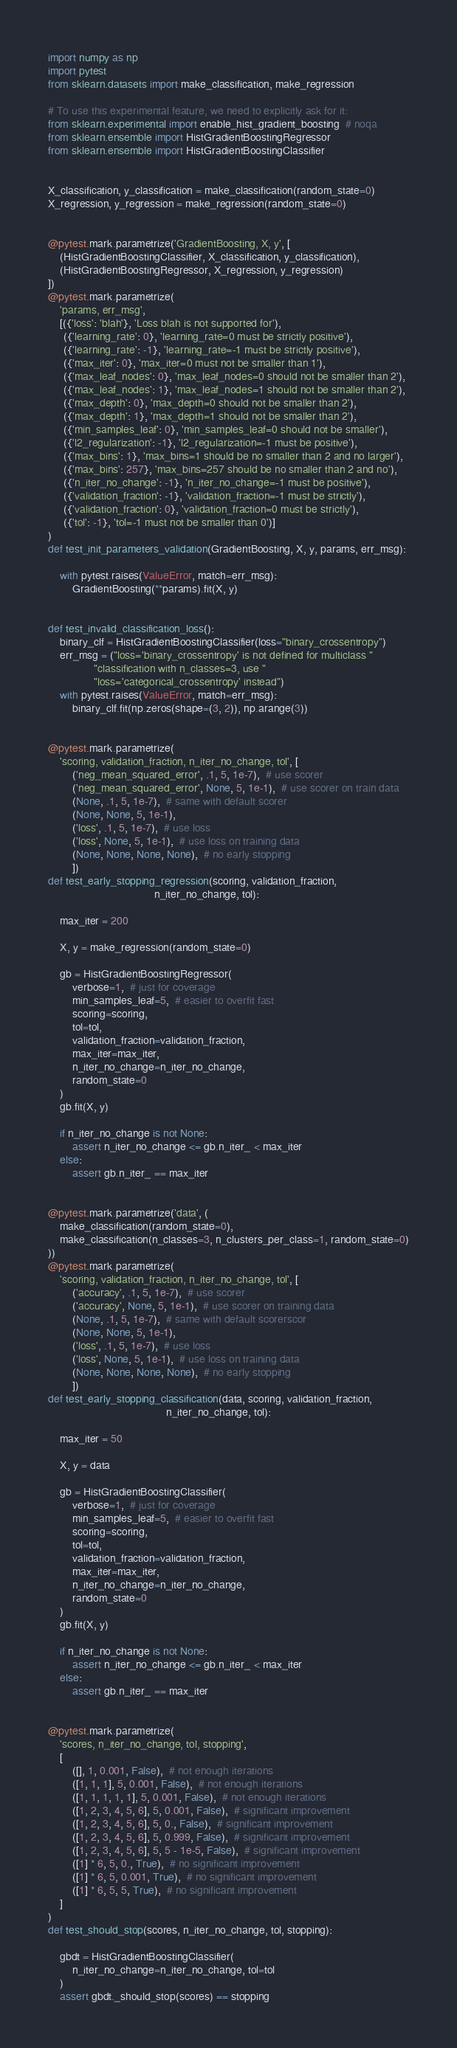<code> <loc_0><loc_0><loc_500><loc_500><_Python_>import numpy as np
import pytest
from sklearn.datasets import make_classification, make_regression

# To use this experimental feature, we need to explicitly ask for it:
from sklearn.experimental import enable_hist_gradient_boosting  # noqa
from sklearn.ensemble import HistGradientBoostingRegressor
from sklearn.ensemble import HistGradientBoostingClassifier


X_classification, y_classification = make_classification(random_state=0)
X_regression, y_regression = make_regression(random_state=0)


@pytest.mark.parametrize('GradientBoosting, X, y', [
    (HistGradientBoostingClassifier, X_classification, y_classification),
    (HistGradientBoostingRegressor, X_regression, y_regression)
])
@pytest.mark.parametrize(
    'params, err_msg',
    [({'loss': 'blah'}, 'Loss blah is not supported for'),
     ({'learning_rate': 0}, 'learning_rate=0 must be strictly positive'),
     ({'learning_rate': -1}, 'learning_rate=-1 must be strictly positive'),
     ({'max_iter': 0}, 'max_iter=0 must not be smaller than 1'),
     ({'max_leaf_nodes': 0}, 'max_leaf_nodes=0 should not be smaller than 2'),
     ({'max_leaf_nodes': 1}, 'max_leaf_nodes=1 should not be smaller than 2'),
     ({'max_depth': 0}, 'max_depth=0 should not be smaller than 2'),
     ({'max_depth': 1}, 'max_depth=1 should not be smaller than 2'),
     ({'min_samples_leaf': 0}, 'min_samples_leaf=0 should not be smaller'),
     ({'l2_regularization': -1}, 'l2_regularization=-1 must be positive'),
     ({'max_bins': 1}, 'max_bins=1 should be no smaller than 2 and no larger'),
     ({'max_bins': 257}, 'max_bins=257 should be no smaller than 2 and no'),
     ({'n_iter_no_change': -1}, 'n_iter_no_change=-1 must be positive'),
     ({'validation_fraction': -1}, 'validation_fraction=-1 must be strictly'),
     ({'validation_fraction': 0}, 'validation_fraction=0 must be strictly'),
     ({'tol': -1}, 'tol=-1 must not be smaller than 0')]
)
def test_init_parameters_validation(GradientBoosting, X, y, params, err_msg):

    with pytest.raises(ValueError, match=err_msg):
        GradientBoosting(**params).fit(X, y)


def test_invalid_classification_loss():
    binary_clf = HistGradientBoostingClassifier(loss="binary_crossentropy")
    err_msg = ("loss='binary_crossentropy' is not defined for multiclass "
               "classification with n_classes=3, use "
               "loss='categorical_crossentropy' instead")
    with pytest.raises(ValueError, match=err_msg):
        binary_clf.fit(np.zeros(shape=(3, 2)), np.arange(3))


@pytest.mark.parametrize(
    'scoring, validation_fraction, n_iter_no_change, tol', [
        ('neg_mean_squared_error', .1, 5, 1e-7),  # use scorer
        ('neg_mean_squared_error', None, 5, 1e-1),  # use scorer on train data
        (None, .1, 5, 1e-7),  # same with default scorer
        (None, None, 5, 1e-1),
        ('loss', .1, 5, 1e-7),  # use loss
        ('loss', None, 5, 1e-1),  # use loss on training data
        (None, None, None, None),  # no early stopping
        ])
def test_early_stopping_regression(scoring, validation_fraction,
                                   n_iter_no_change, tol):

    max_iter = 200

    X, y = make_regression(random_state=0)

    gb = HistGradientBoostingRegressor(
        verbose=1,  # just for coverage
        min_samples_leaf=5,  # easier to overfit fast
        scoring=scoring,
        tol=tol,
        validation_fraction=validation_fraction,
        max_iter=max_iter,
        n_iter_no_change=n_iter_no_change,
        random_state=0
    )
    gb.fit(X, y)

    if n_iter_no_change is not None:
        assert n_iter_no_change <= gb.n_iter_ < max_iter
    else:
        assert gb.n_iter_ == max_iter


@pytest.mark.parametrize('data', (
    make_classification(random_state=0),
    make_classification(n_classes=3, n_clusters_per_class=1, random_state=0)
))
@pytest.mark.parametrize(
    'scoring, validation_fraction, n_iter_no_change, tol', [
        ('accuracy', .1, 5, 1e-7),  # use scorer
        ('accuracy', None, 5, 1e-1),  # use scorer on training data
        (None, .1, 5, 1e-7),  # same with default scorerscor
        (None, None, 5, 1e-1),
        ('loss', .1, 5, 1e-7),  # use loss
        ('loss', None, 5, 1e-1),  # use loss on training data
        (None, None, None, None),  # no early stopping
        ])
def test_early_stopping_classification(data, scoring, validation_fraction,
                                       n_iter_no_change, tol):

    max_iter = 50

    X, y = data

    gb = HistGradientBoostingClassifier(
        verbose=1,  # just for coverage
        min_samples_leaf=5,  # easier to overfit fast
        scoring=scoring,
        tol=tol,
        validation_fraction=validation_fraction,
        max_iter=max_iter,
        n_iter_no_change=n_iter_no_change,
        random_state=0
    )
    gb.fit(X, y)

    if n_iter_no_change is not None:
        assert n_iter_no_change <= gb.n_iter_ < max_iter
    else:
        assert gb.n_iter_ == max_iter


@pytest.mark.parametrize(
    'scores, n_iter_no_change, tol, stopping',
    [
        ([], 1, 0.001, False),  # not enough iterations
        ([1, 1, 1], 5, 0.001, False),  # not enough iterations
        ([1, 1, 1, 1, 1], 5, 0.001, False),  # not enough iterations
        ([1, 2, 3, 4, 5, 6], 5, 0.001, False),  # significant improvement
        ([1, 2, 3, 4, 5, 6], 5, 0., False),  # significant improvement
        ([1, 2, 3, 4, 5, 6], 5, 0.999, False),  # significant improvement
        ([1, 2, 3, 4, 5, 6], 5, 5 - 1e-5, False),  # significant improvement
        ([1] * 6, 5, 0., True),  # no significant improvement
        ([1] * 6, 5, 0.001, True),  # no significant improvement
        ([1] * 6, 5, 5, True),  # no significant improvement
    ]
)
def test_should_stop(scores, n_iter_no_change, tol, stopping):

    gbdt = HistGradientBoostingClassifier(
        n_iter_no_change=n_iter_no_change, tol=tol
    )
    assert gbdt._should_stop(scores) == stopping
</code> 